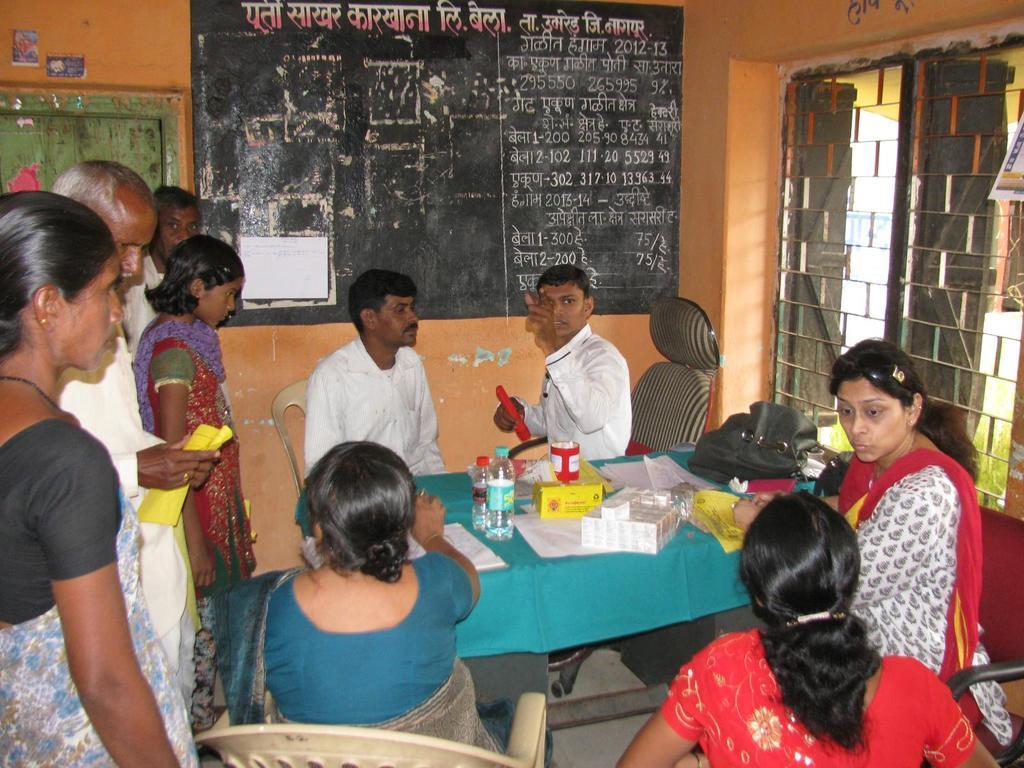Please provide a concise description of this image. In the image we can see there are people standing and some of them are sitting, they are wearing clothes. Here we can see a table, on the table, we can see a water bottle, handbag, papers and medicines. There are even chairs, here we can see a blackboard window, window fence and a door. 